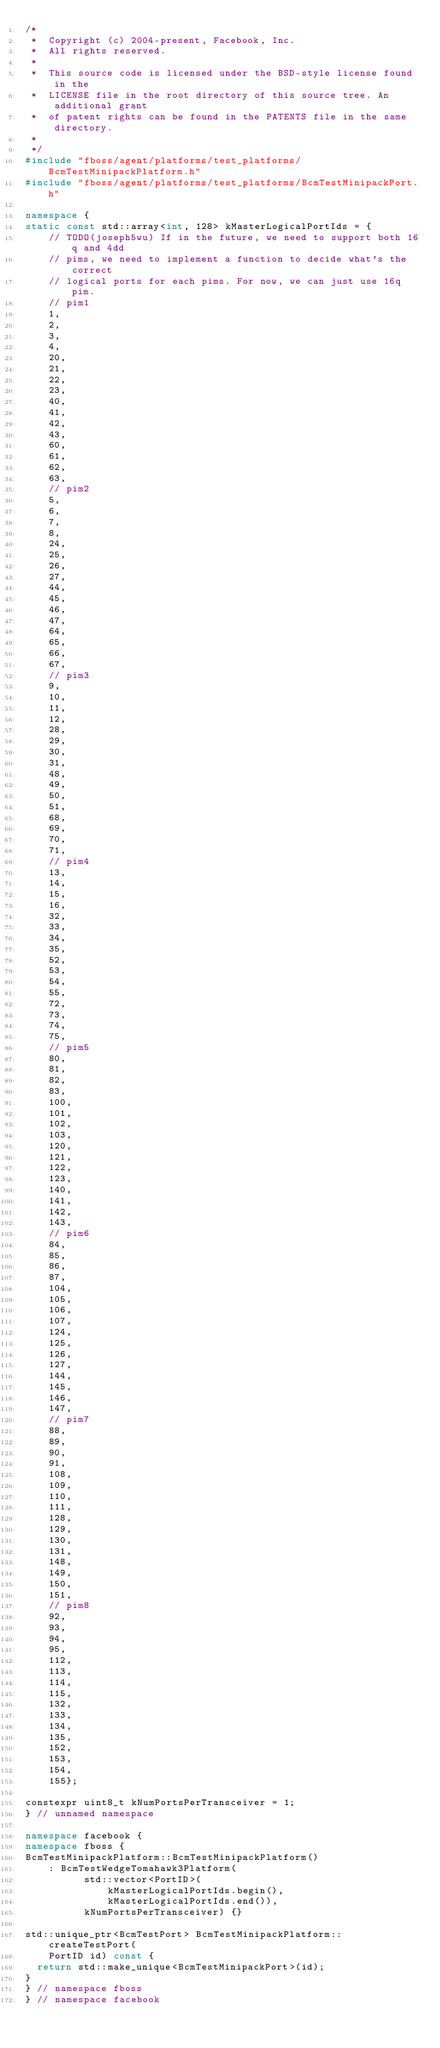Convert code to text. <code><loc_0><loc_0><loc_500><loc_500><_C++_>/*
 *  Copyright (c) 2004-present, Facebook, Inc.
 *  All rights reserved.
 *
 *  This source code is licensed under the BSD-style license found in the
 *  LICENSE file in the root directory of this source tree. An additional grant
 *  of patent rights can be found in the PATENTS file in the same directory.
 *
 */
#include "fboss/agent/platforms/test_platforms/BcmTestMinipackPlatform.h"
#include "fboss/agent/platforms/test_platforms/BcmTestMinipackPort.h"

namespace {
static const std::array<int, 128> kMasterLogicalPortIds = {
    // TODO(joseph5wu) If in the future, we need to support both 16q and 4dd
    // pims, we need to implement a function to decide what's the correct
    // logical ports for each pims. For now, we can just use 16q pim.
    // pim1
    1,
    2,
    3,
    4,
    20,
    21,
    22,
    23,
    40,
    41,
    42,
    43,
    60,
    61,
    62,
    63,
    // pim2
    5,
    6,
    7,
    8,
    24,
    25,
    26,
    27,
    44,
    45,
    46,
    47,
    64,
    65,
    66,
    67,
    // pim3
    9,
    10,
    11,
    12,
    28,
    29,
    30,
    31,
    48,
    49,
    50,
    51,
    68,
    69,
    70,
    71,
    // pim4
    13,
    14,
    15,
    16,
    32,
    33,
    34,
    35,
    52,
    53,
    54,
    55,
    72,
    73,
    74,
    75,
    // pim5
    80,
    81,
    82,
    83,
    100,
    101,
    102,
    103,
    120,
    121,
    122,
    123,
    140,
    141,
    142,
    143,
    // pim6
    84,
    85,
    86,
    87,
    104,
    105,
    106,
    107,
    124,
    125,
    126,
    127,
    144,
    145,
    146,
    147,
    // pim7
    88,
    89,
    90,
    91,
    108,
    109,
    110,
    111,
    128,
    129,
    130,
    131,
    148,
    149,
    150,
    151,
    // pim8
    92,
    93,
    94,
    95,
    112,
    113,
    114,
    115,
    132,
    133,
    134,
    135,
    152,
    153,
    154,
    155};

constexpr uint8_t kNumPortsPerTransceiver = 1;
} // unnamed namespace

namespace facebook {
namespace fboss {
BcmTestMinipackPlatform::BcmTestMinipackPlatform()
    : BcmTestWedgeTomahawk3Platform(
          std::vector<PortID>(
              kMasterLogicalPortIds.begin(),
              kMasterLogicalPortIds.end()),
          kNumPortsPerTransceiver) {}

std::unique_ptr<BcmTestPort> BcmTestMinipackPlatform::createTestPort(
    PortID id) const {
  return std::make_unique<BcmTestMinipackPort>(id);
}
} // namespace fboss
} // namespace facebook
</code> 